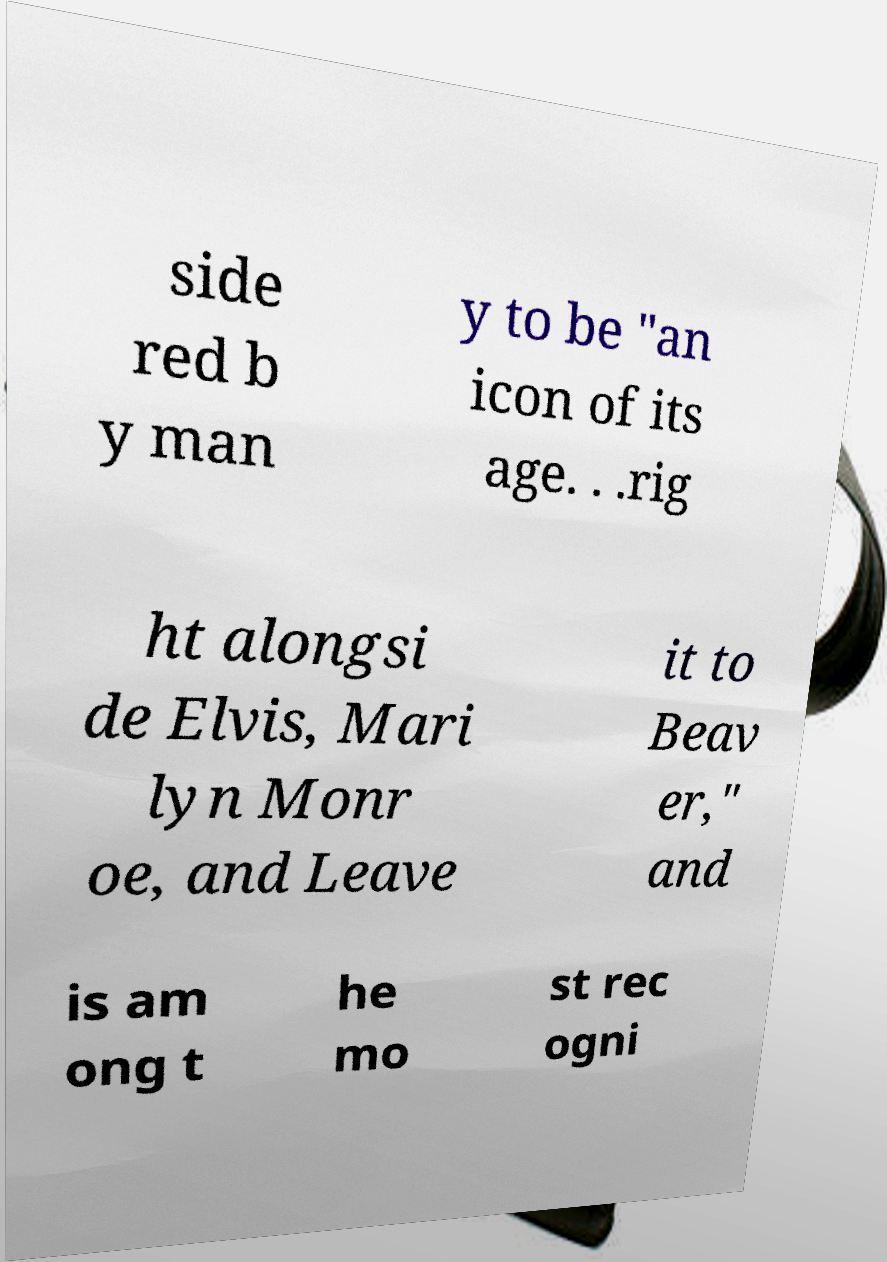Please read and relay the text visible in this image. What does it say? side red b y man y to be "an icon of its age. . .rig ht alongsi de Elvis, Mari lyn Monr oe, and Leave it to Beav er," and is am ong t he mo st rec ogni 